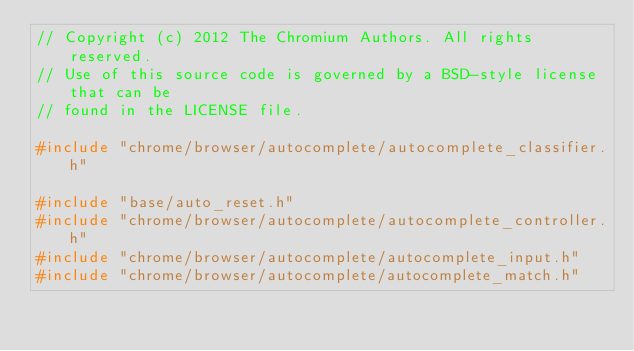<code> <loc_0><loc_0><loc_500><loc_500><_C++_>// Copyright (c) 2012 The Chromium Authors. All rights reserved.
// Use of this source code is governed by a BSD-style license that can be
// found in the LICENSE file.

#include "chrome/browser/autocomplete/autocomplete_classifier.h"

#include "base/auto_reset.h"
#include "chrome/browser/autocomplete/autocomplete_controller.h"
#include "chrome/browser/autocomplete/autocomplete_input.h"
#include "chrome/browser/autocomplete/autocomplete_match.h"</code> 